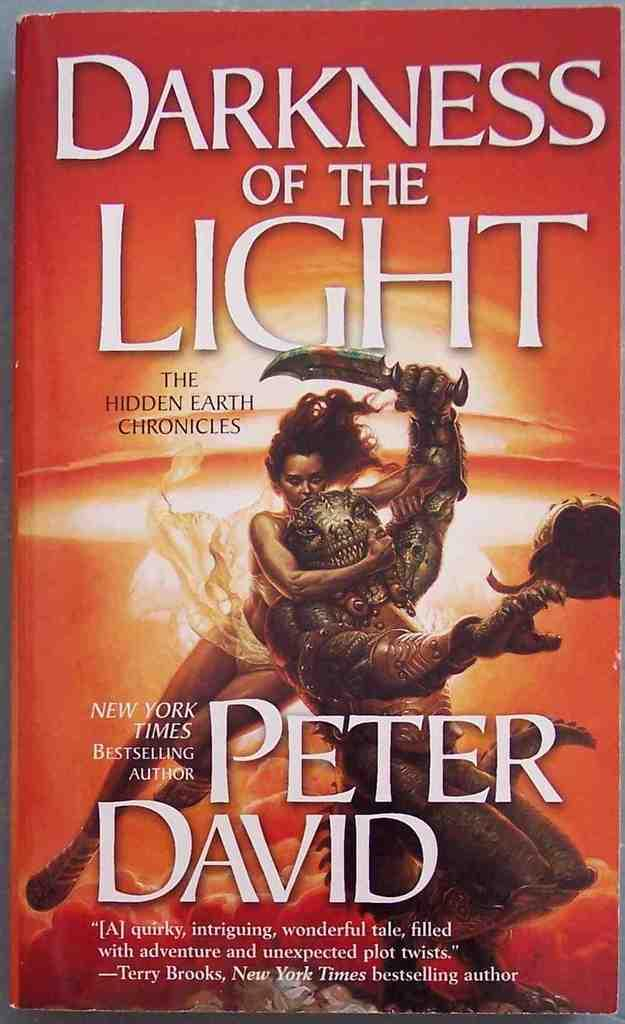Provide a one-sentence caption for the provided image. A book by bestselling author Peter David titled Darkness of the Light. 